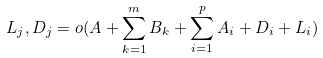<formula> <loc_0><loc_0><loc_500><loc_500>L _ { j } , D _ { j } = o ( A + \sum ^ { m } _ { k = 1 } B _ { k } + \sum ^ { p } _ { i = 1 } A _ { i } + D _ { i } + L _ { i } )</formula> 